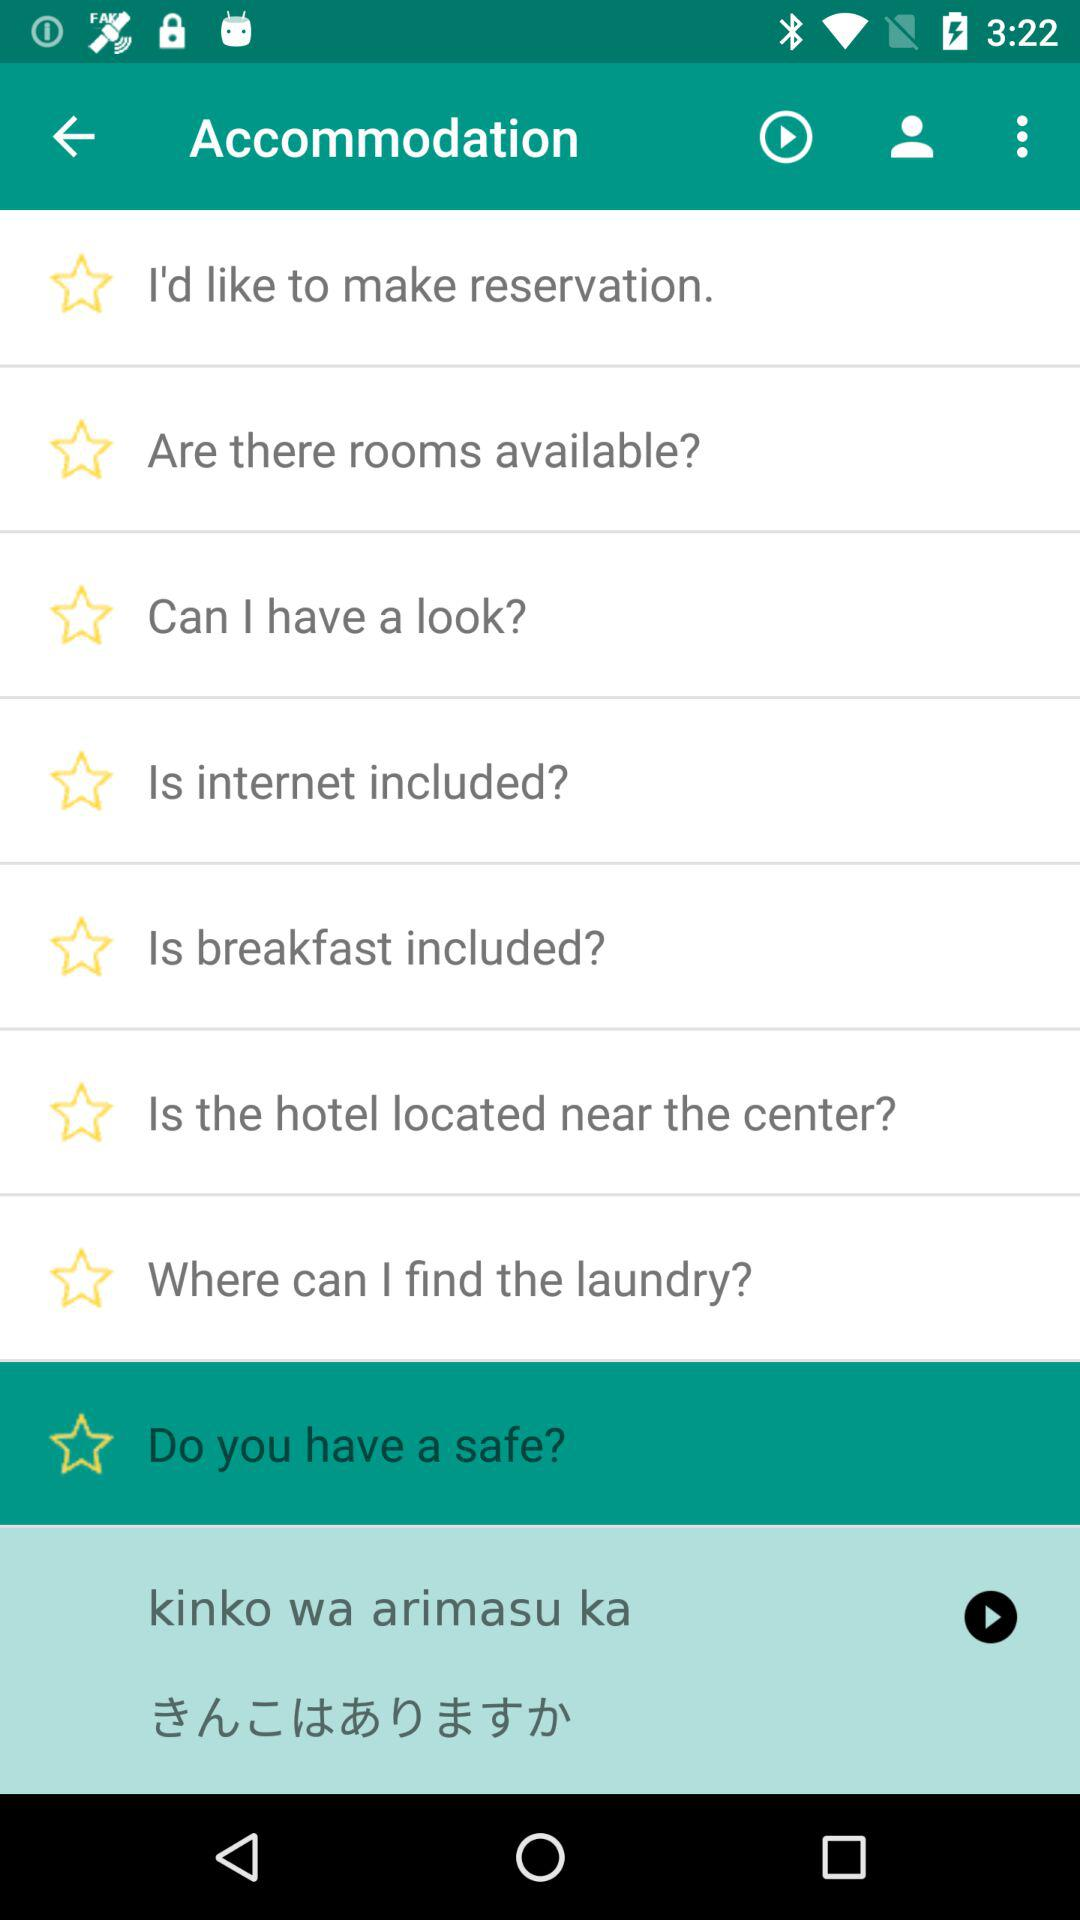Which option is selected? The selected option is "Do you have a safe?". 